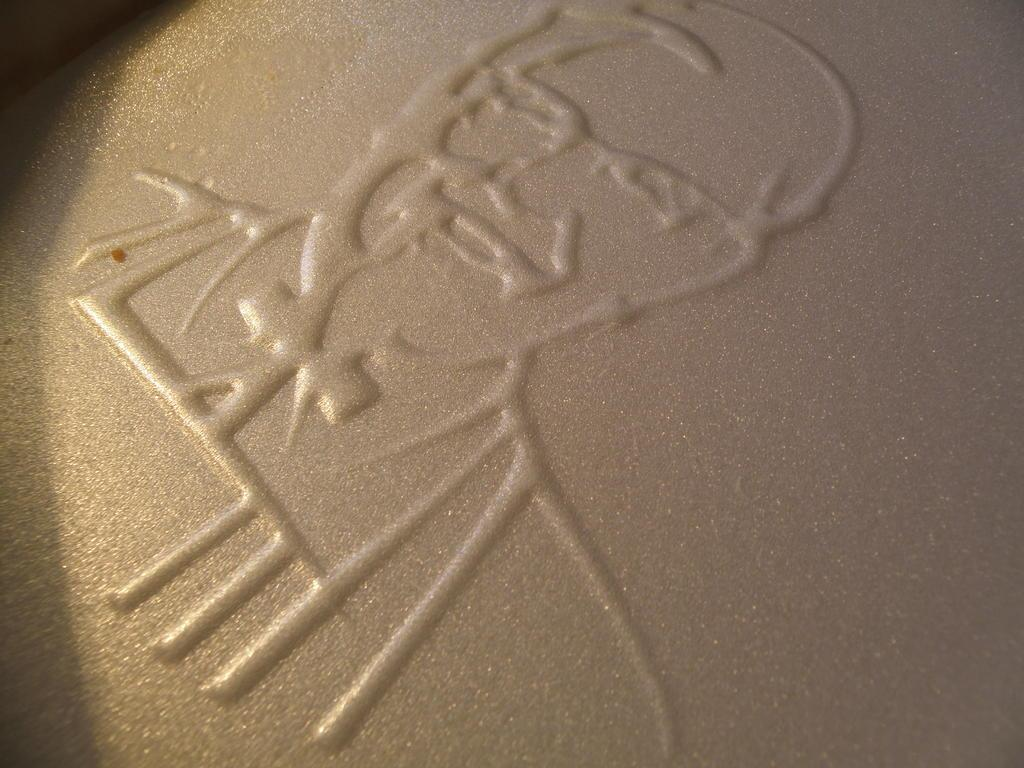What is the main subject of the image? There is art in the image. What is the background or surface of the art? The art is on a cream surface. Can you see a crow using its wing to fly in the image? There is no crow or wing present in the image; it features art on a cream surface. 